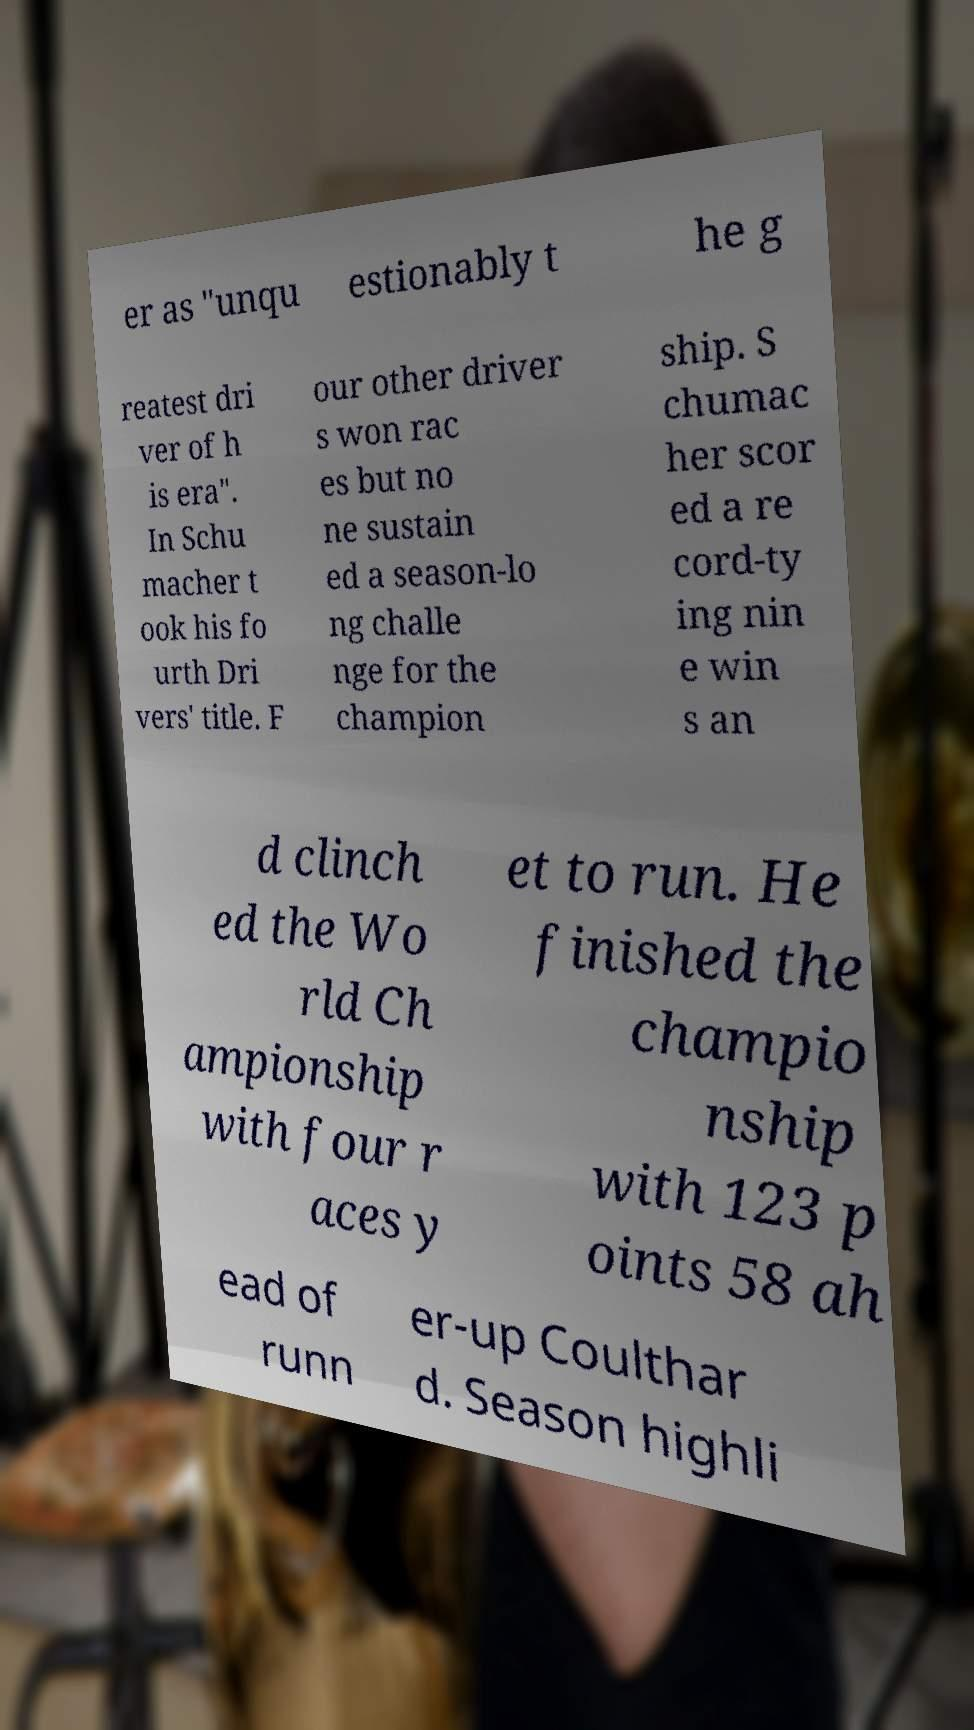There's text embedded in this image that I need extracted. Can you transcribe it verbatim? er as "unqu estionably t he g reatest dri ver of h is era". In Schu macher t ook his fo urth Dri vers' title. F our other driver s won rac es but no ne sustain ed a season-lo ng challe nge for the champion ship. S chumac her scor ed a re cord-ty ing nin e win s an d clinch ed the Wo rld Ch ampionship with four r aces y et to run. He finished the champio nship with 123 p oints 58 ah ead of runn er-up Coulthar d. Season highli 